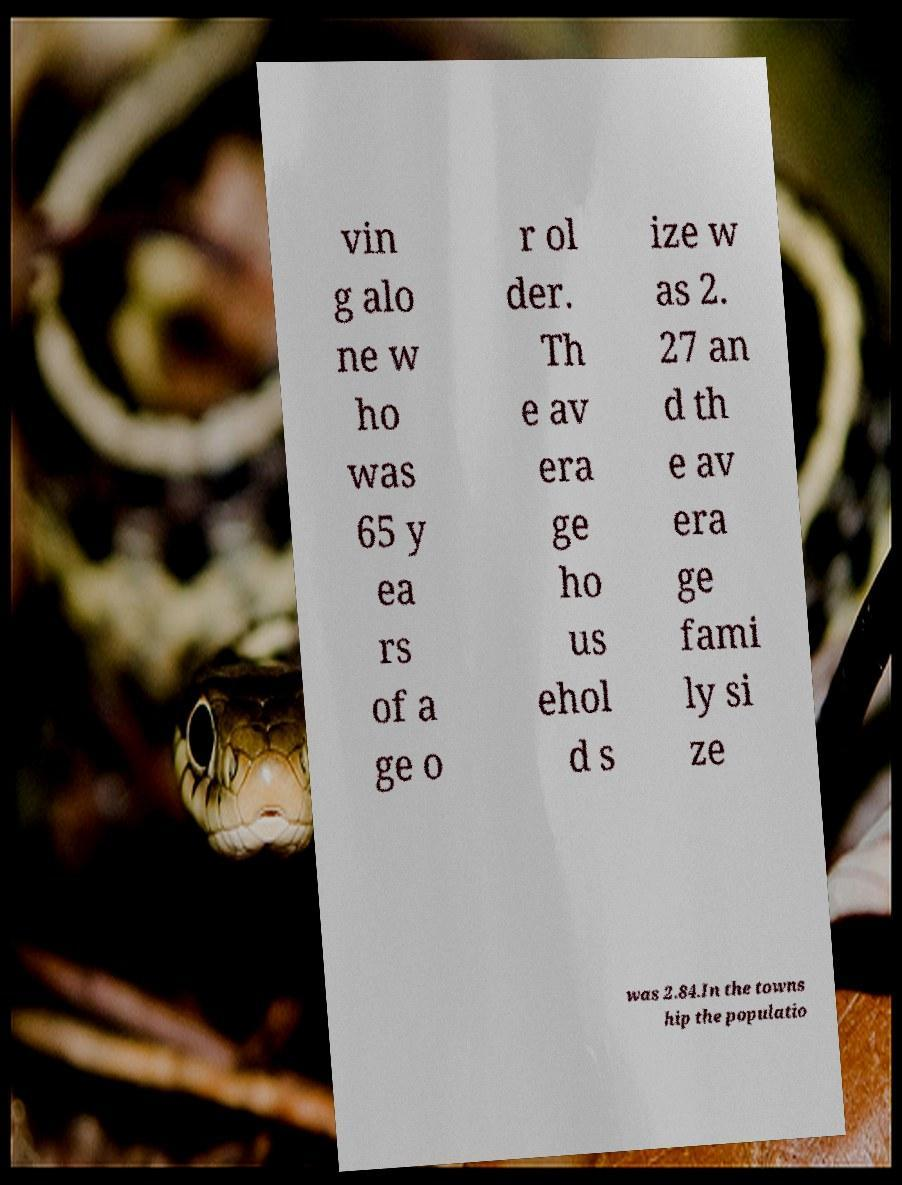I need the written content from this picture converted into text. Can you do that? vin g alo ne w ho was 65 y ea rs of a ge o r ol der. Th e av era ge ho us ehol d s ize w as 2. 27 an d th e av era ge fami ly si ze was 2.84.In the towns hip the populatio 